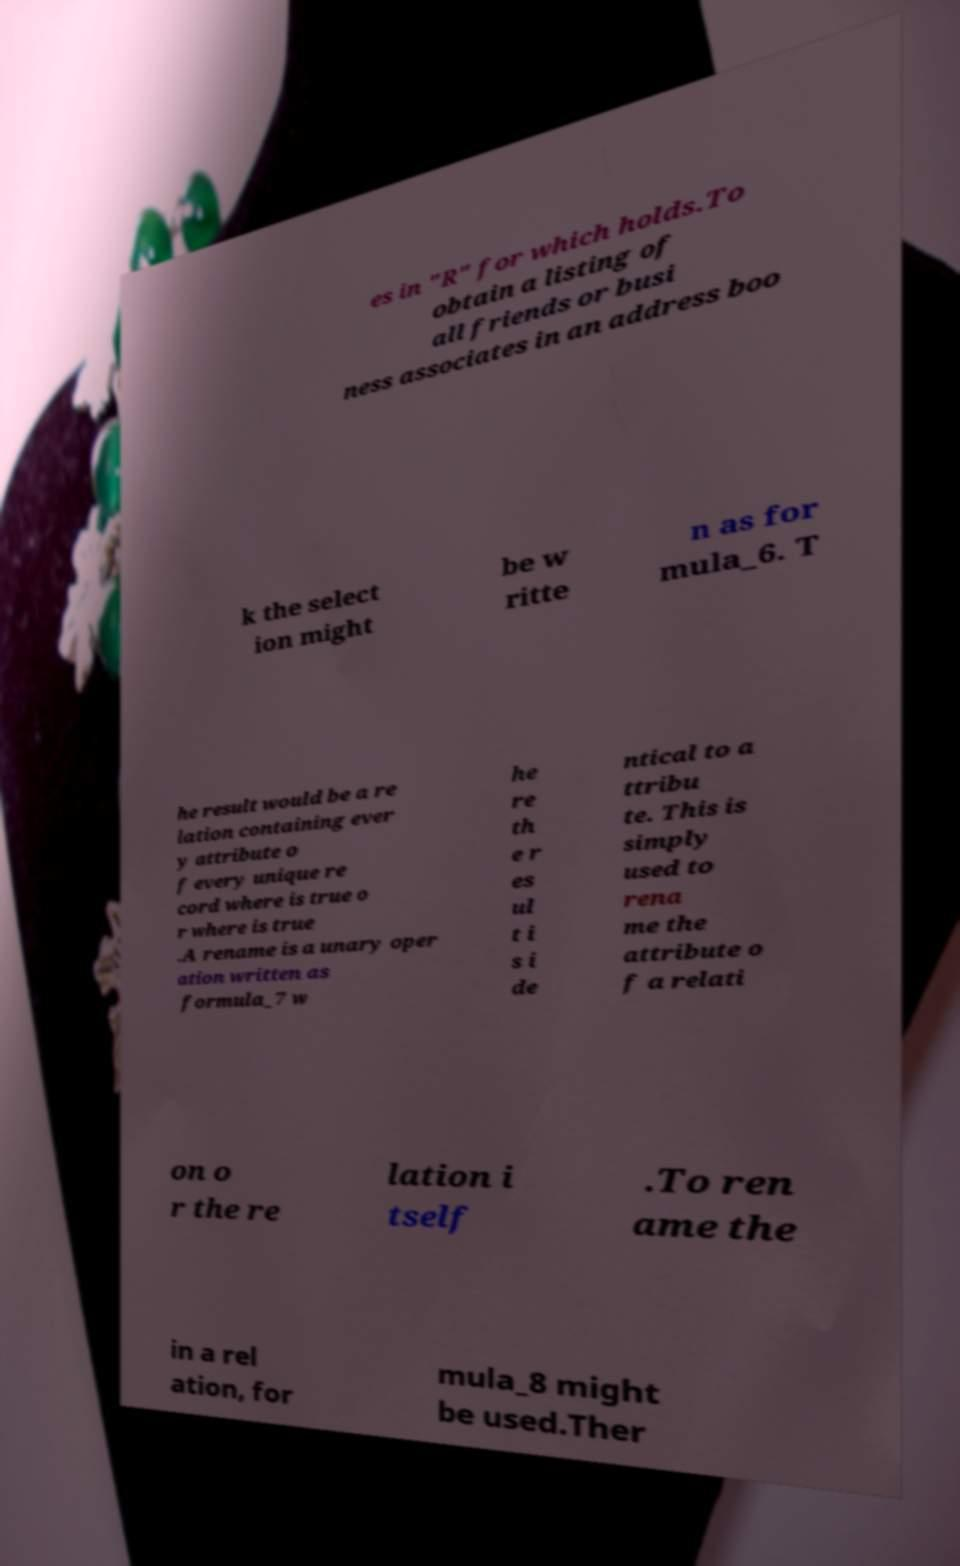What messages or text are displayed in this image? I need them in a readable, typed format. es in "R" for which holds.To obtain a listing of all friends or busi ness associates in an address boo k the select ion might be w ritte n as for mula_6. T he result would be a re lation containing ever y attribute o f every unique re cord where is true o r where is true .A rename is a unary oper ation written as formula_7 w he re th e r es ul t i s i de ntical to a ttribu te. This is simply used to rena me the attribute o f a relati on o r the re lation i tself .To ren ame the in a rel ation, for mula_8 might be used.Ther 